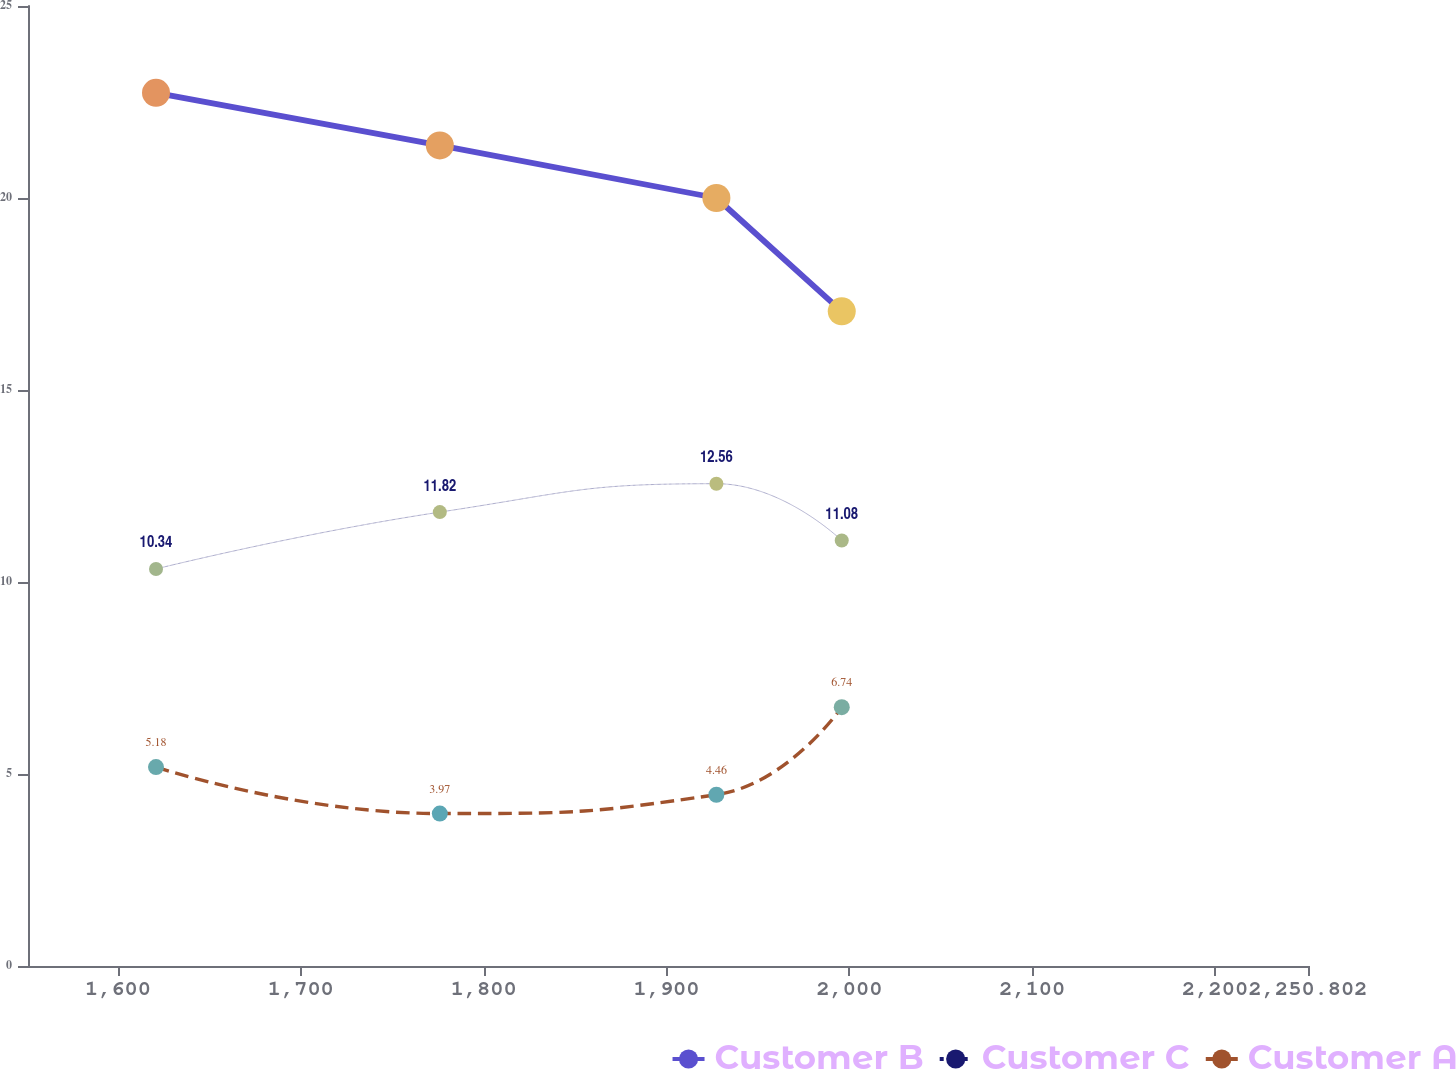<chart> <loc_0><loc_0><loc_500><loc_500><line_chart><ecel><fcel>Customer B<fcel>Customer C<fcel>Customer A<nl><fcel>1620.82<fcel>22.74<fcel>10.34<fcel>5.18<nl><fcel>1776.03<fcel>21.37<fcel>11.82<fcel>3.97<nl><fcel>1927.28<fcel>20<fcel>12.56<fcel>4.46<nl><fcel>1995.83<fcel>17.05<fcel>11.08<fcel>6.74<nl><fcel>2252.25<fcel>24.11<fcel>17.75<fcel>7.86<nl><fcel>2320.8<fcel>30.77<fcel>15.99<fcel>2.97<nl></chart> 